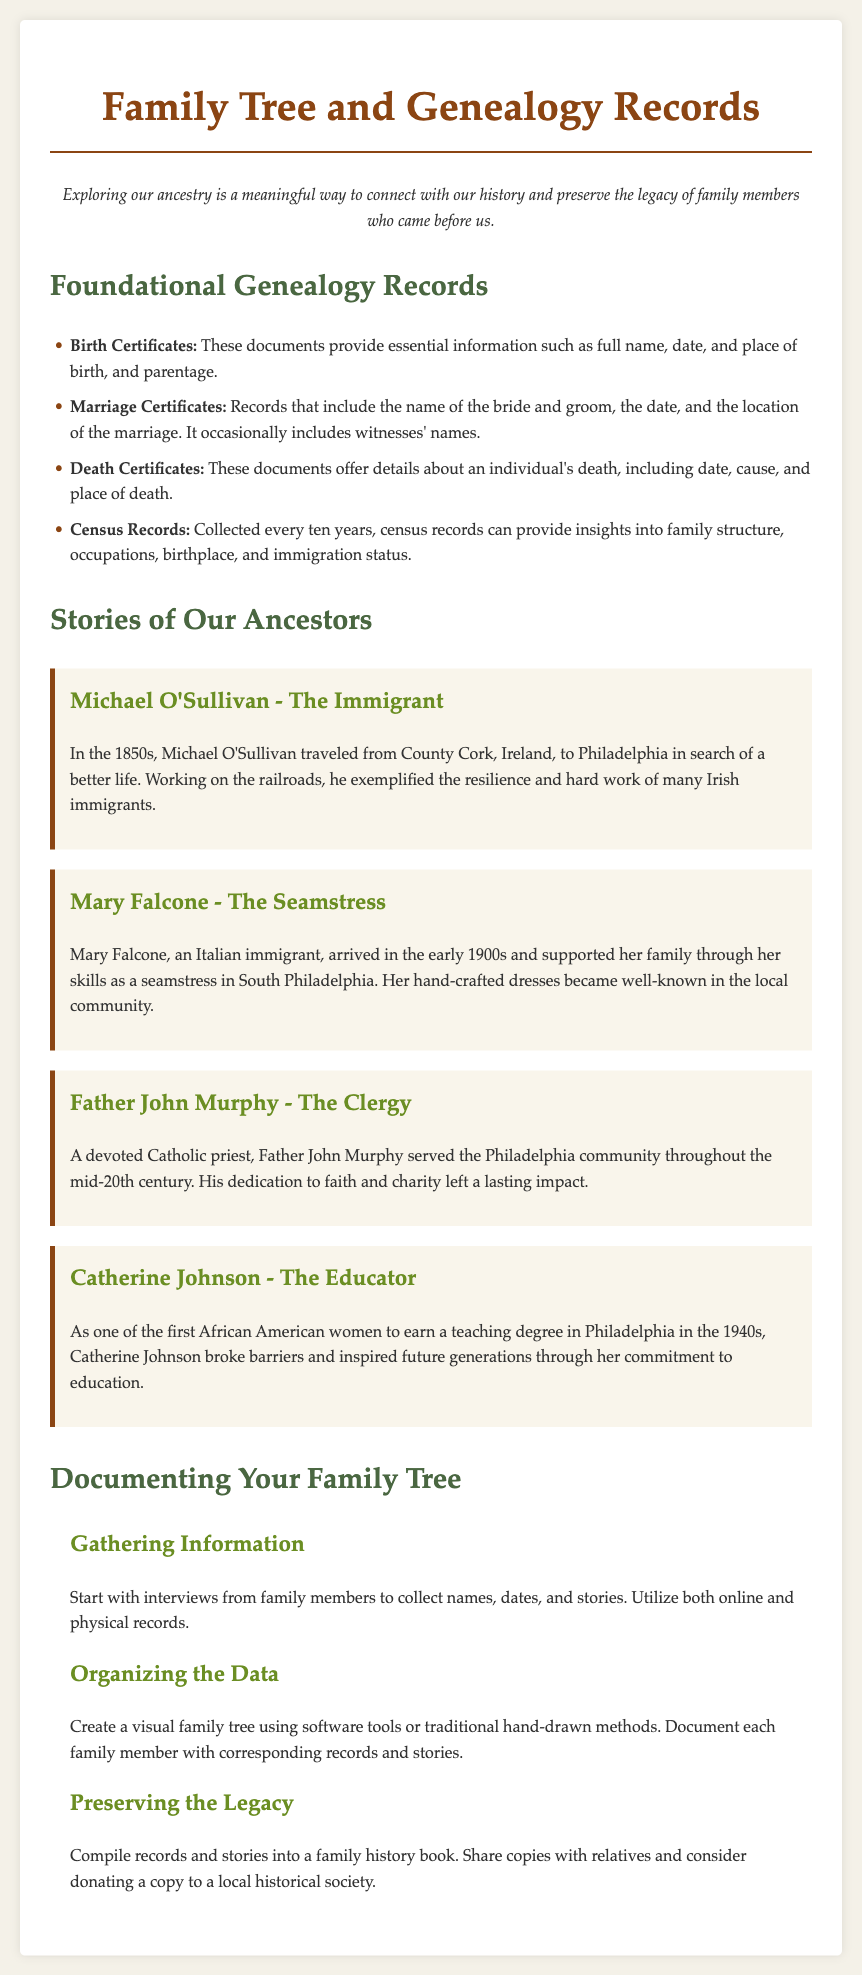What are foundational genealogy records? Foundational genealogy records are essential documents that provide insights into family history, including birth, marriage, and death information.
Answer: Birth Certificates, Marriage Certificates, Death Certificates, Census Records Who was the immigrant from County Cork? The document mentions Michael O'Sullivan as the immigrant who traveled from County Cork, Ireland.
Answer: Michael O'Sullivan What decade did Mary Falcone arrive in the U.S.? Mary Falcone arrived in the U.S. in the early 1900s.
Answer: early 1900s What is one way to preserve family history? The document suggests compiling records and stories into a family history book as a method of preservation.
Answer: Family history book Who served as a Catholic priest in Philadelphia? Father John Murphy is identified as the Catholic priest who served the Philadelphia community.
Answer: Father John Murphy Which ancestor broke barriers in education? Catherine Johnson is mentioned as the ancestor who broke barriers as one of the first African American women to earn a teaching degree.
Answer: Catherine Johnson What is a suggested first step in documenting your family tree? The document recommends starting with interviews from family members to gather information.
Answer: Interviews from family members Which document offers information about an individual's death? The document indicates that death certificates provide information about an individual’s death.
Answer: Death Certificates 